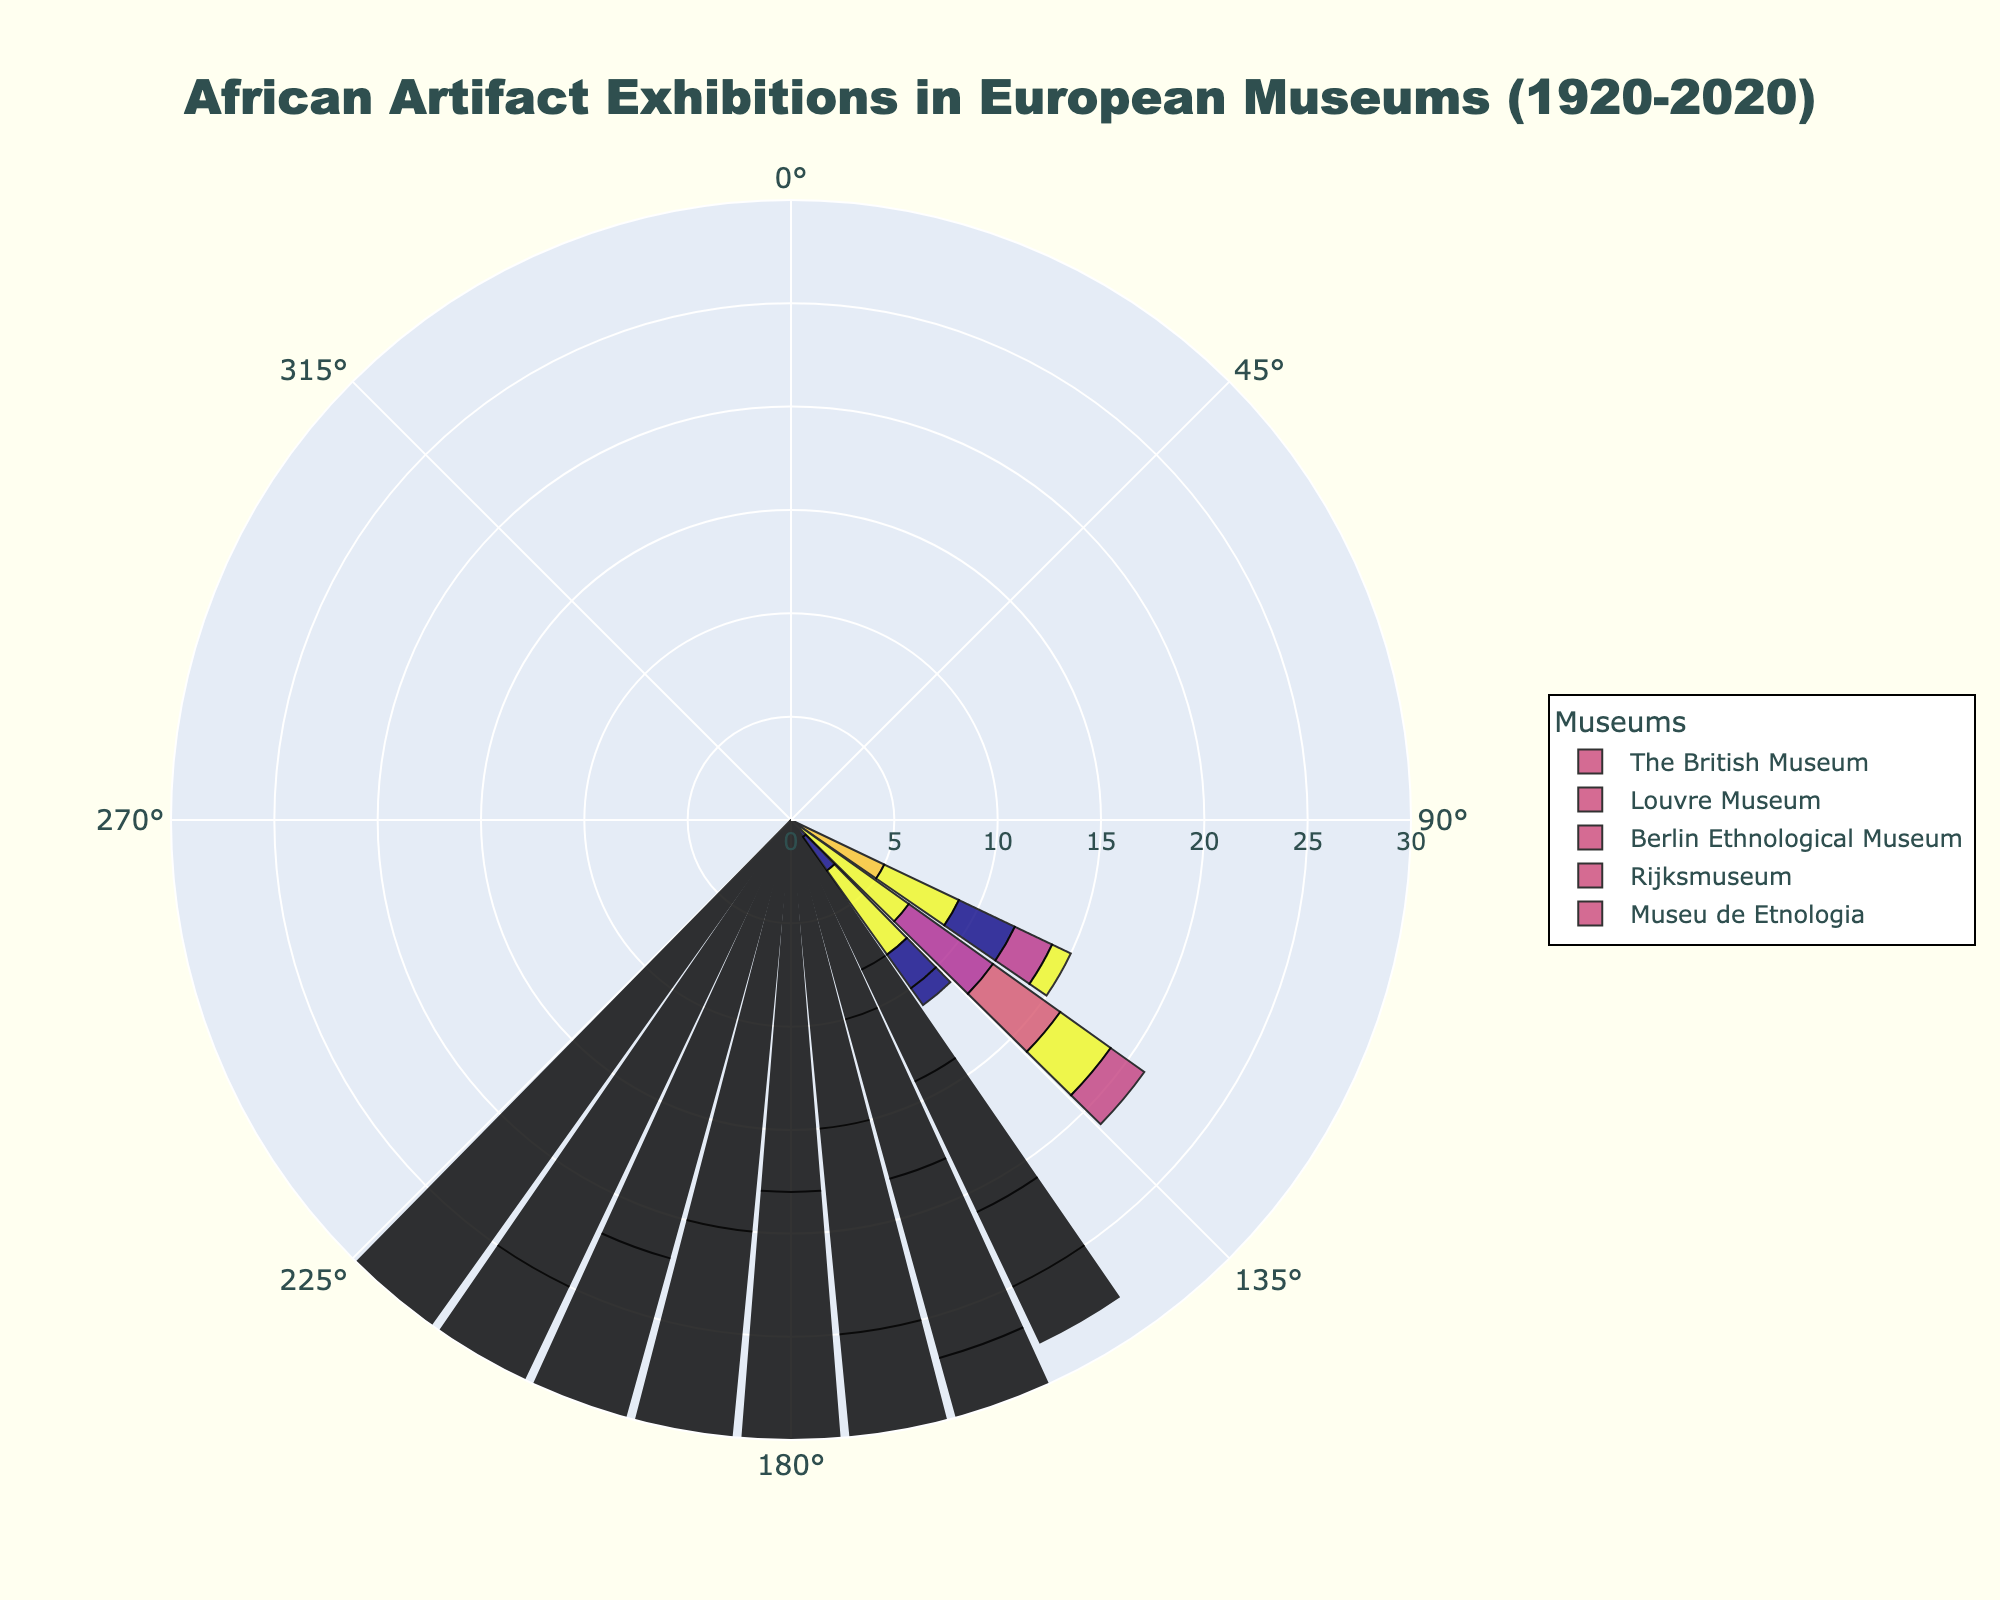What is the title of the figure? The title of the figure is usually displayed at the top and summarizes what the chart is about. In this case, the title is "African Artifact Exhibitions in European Museums (1920-2020)".
Answer: African Artifact Exhibitions in European Museums (1920-2020) Which museum had the highest number of African artifact exhibitions in 2020? Look at the chart and find the value corresponding to the year 2020 for each museum. The museum with the tallest bar in this year is The British Museum with a value of 30.
Answer: The British Museum What is the average number of African artifact exhibitions held by the Louvre Museum from 1920 to 2020? Sum the values for the Louvre Museum for each decade from 1920 to 2020 and then divide by the number of decades, which is 11. The sum is 4+5+2+6+8+10+13+16+18+20+25 = 127, divided by 11 equals 11.545.
Answer: 11.545 Which decade saw the greatest increase in the number of African artifact exhibitions at the Berlin Ethnological Museum? Calculate the differences between each adjacent decade for the Berlin Ethnological Museum. The differences are: (4-3=1), (5-4=1), (7-5=2), (9-7=2), (12-9=3), (15-12=3), (18-15=3), (20-18=2), (23-20=3), and (28-23=5). The greatest increase of 5 occurred between 2010 and 2020.
Answer: 2010-2020 Between the Rijksmuseum and Museu de Etnologia, which had a higher number of exhibitions in the year 1980? Compare the values for Rijksmuseum and Museu de Etnologia for the year 1980. Rijksmuseum had 10 exhibitions, and Museu de Etnologia had 8 exhibitions.
Answer: Rijksmuseum How many more exhibitions did The British Museum have compared to the Rijksmuseum in 2020? Find the values for The British Museum and Rijksmuseum in 2020, which are 30 and 20, respectively. Subtract the smaller value from the larger value (30-20=10). So, The British Museum had 10 more exhibitions.
Answer: 10 more exhibitions What's the median value of African artifact exhibitions held by the Louvre Museum throughout the century? First, arrange the Louvre Museum data in ascending order: 2, 4, 5, 6, 8, 10, 13, 16, 18, 20, 25. The median is the middle value of this ordered list. With 11 values, the middle one is the 6th value, which is 10.
Answer: 10 Compare the average number of exhibitions held in the 1990s across all museums. Which museum had the highest average? Calculate the average number of exhibitions for each museum in the 1990s by summing their values for 1990 and dividing by the number of years (which is 1 in this case). The averages are: 
- The British Museum: 20
- Louvre Museum: 16
- Berlin Ethnological Museum: 18
- Rijksmuseum: 12
- Museu de Etnologia: 10
The British Museum has the highest average at 20.
Answer: The British Museum Which museum showed the most consistent increase in exhibitions over the decades? Consistent increase means the values increase every decade. Calculate the differences between each adjacent decade for all museums. Verify which museum didn't experience any decrease in any decade between 1920 and 2020. The British Museum values consistently increased every decade.
Answer: The British Museum 